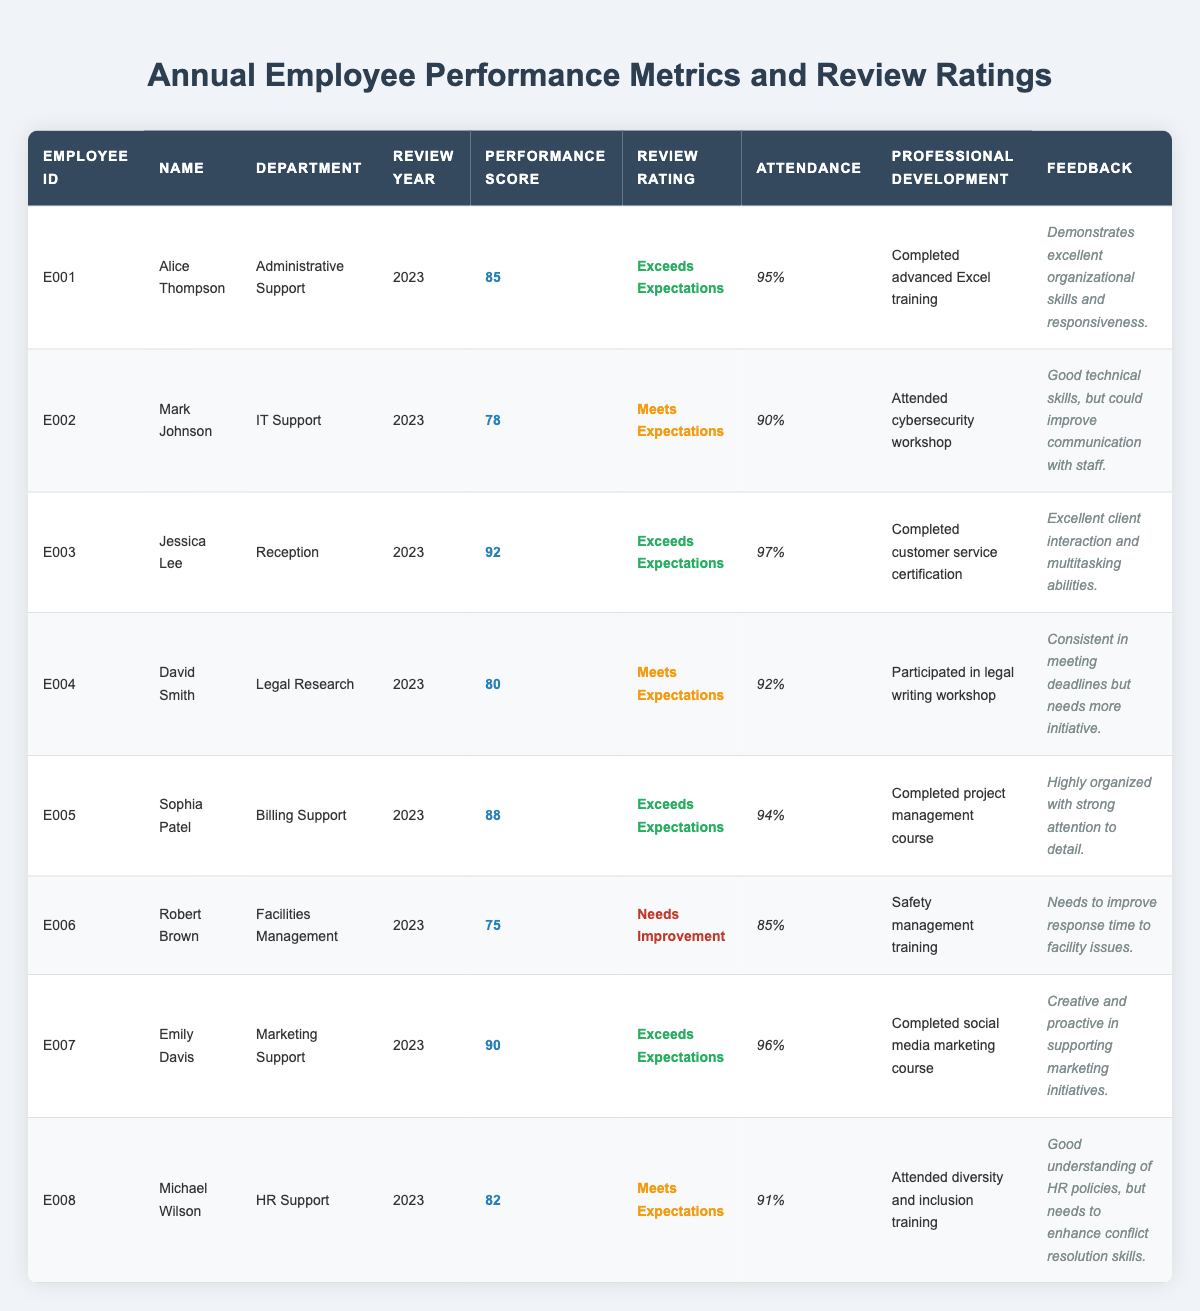What is the performance score of Alice Thompson? Alice Thompson's performance score is listed in the table under her entry, which shows a score of 85.
Answer: 85 Which department does Jessica Lee work in? The table specifies that Jessica Lee is in the Reception department.
Answer: Reception How many employees received a review rating of "Exceeds Expectations"? By reviewing the table, we see that Alice Thompson, Jessica Lee, Sophia Patel, and Emily Davis all have the rating "Exceeds Expectations," totaling 4 employees.
Answer: 4 What is the attendance percentage of Robert Brown? Robert Brown's attendance percentage is displayed in the table as 85%.
Answer: 85% Who has the highest performance score among the support staff? The table reveals that Jessica Lee has the highest performance score at 92.
Answer: Jessica Lee What is the average performance score of all employees listed in the table? To find the average, sum the performance scores (85 + 78 + 92 + 80 + 88 + 75 + 90 + 82 = 720) and divide by the number of employees (8). Thus, the average is 720 / 8 = 90.
Answer: 90 Did any employee receive a feedback indicating the need for improved communication skills? Mark Johnson's feedback states he could improve communication with staff, making the answer yes.
Answer: Yes Which employee has the lowest attendance? The lowest attendance percentage can be found by comparing all attendance figures; Robert Brown has 85%, the lowest of the group.
Answer: Robert Brown Is there a professional development training related to legal skills attended by any employee? David Smith participated in a legal writing workshop, indicating yes, there is a relevant training.
Answer: Yes How many employees need improvement based on their review ratings? The table indicates that only Robert Brown received the rating of "Needs Improvement," so there is 1 employee.
Answer: 1 What is the difference between the highest and lowest performance score earned by the staff? The highest performance score is 92 (Jessica Lee) and the lowest is 75 (Robert Brown). The difference is 92 - 75 = 17.
Answer: 17 Is Emily Davis's attendance higher than Mark Johnson's attendance? By comparing the table entries, Emily Davis has 96% and Mark Johnson has 90%. Since 96% is greater than 90%, the answer is yes.
Answer: Yes Which department has the employee with the longest attendance record? By comparing the attendance records, Jessica Lee has 97%, which is the highest attendance percentage and is in the Reception department.
Answer: Reception What feedback did Sophia Patel receive on her performance? The table shows Sophia Patel's feedback as "Highly organized with strong attention to detail." It indicates positive performance.
Answer: Highly organized with strong attention to detail 